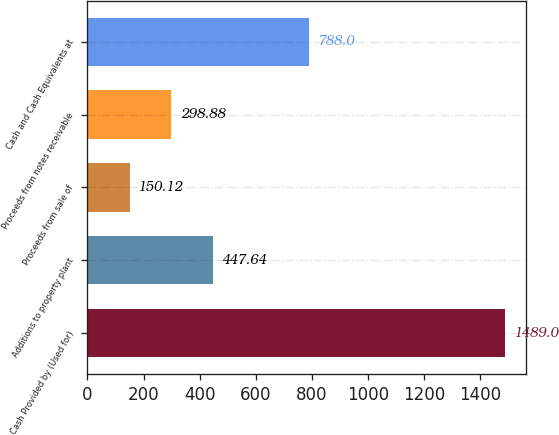Convert chart to OTSL. <chart><loc_0><loc_0><loc_500><loc_500><bar_chart><fcel>Cash Provided by (Used for)<fcel>Additions to property plant<fcel>Proceeds from sale of<fcel>Proceeds from notes receivable<fcel>Cash and Cash Equivalents at<nl><fcel>1489<fcel>447.64<fcel>150.12<fcel>298.88<fcel>788<nl></chart> 